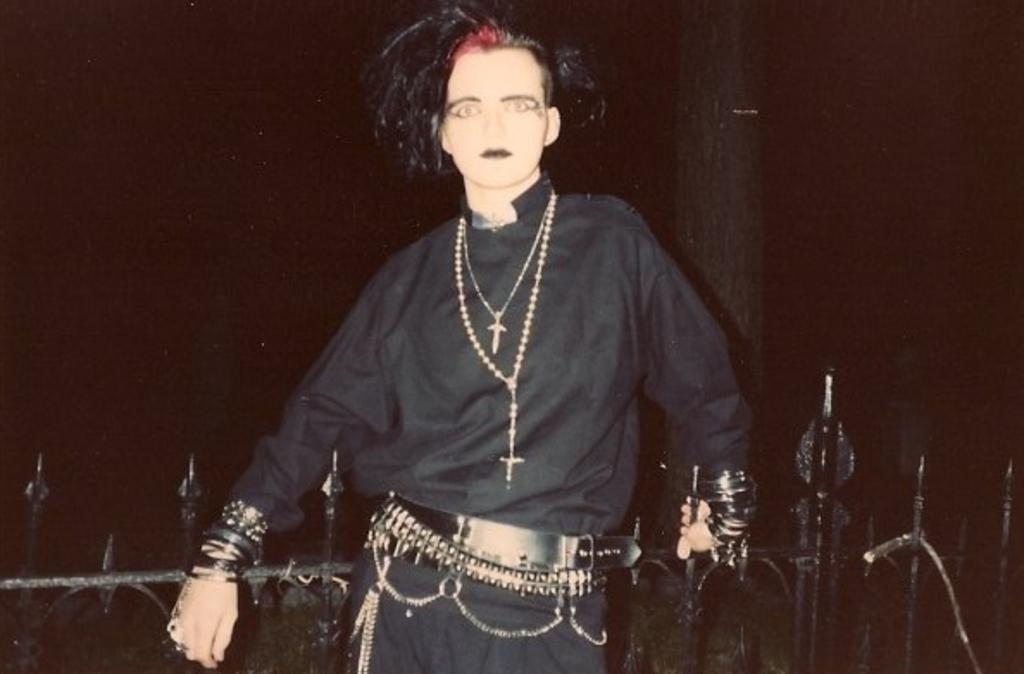What is the main subject of the image? There is a person standing in the image. What type of architectural feature can be seen in the image? There are iron grilles in the image. What natural element is present in the image? There is a tree trunk in the image. How would you describe the lighting in the image? The background of the image appears dark. What type of chalk is being used by the person in the image? There is no chalk present in the image, and the person is not using any chalk. Can you tell me how fast the person is running in the image? The person is not running in the image; they are standing still. 